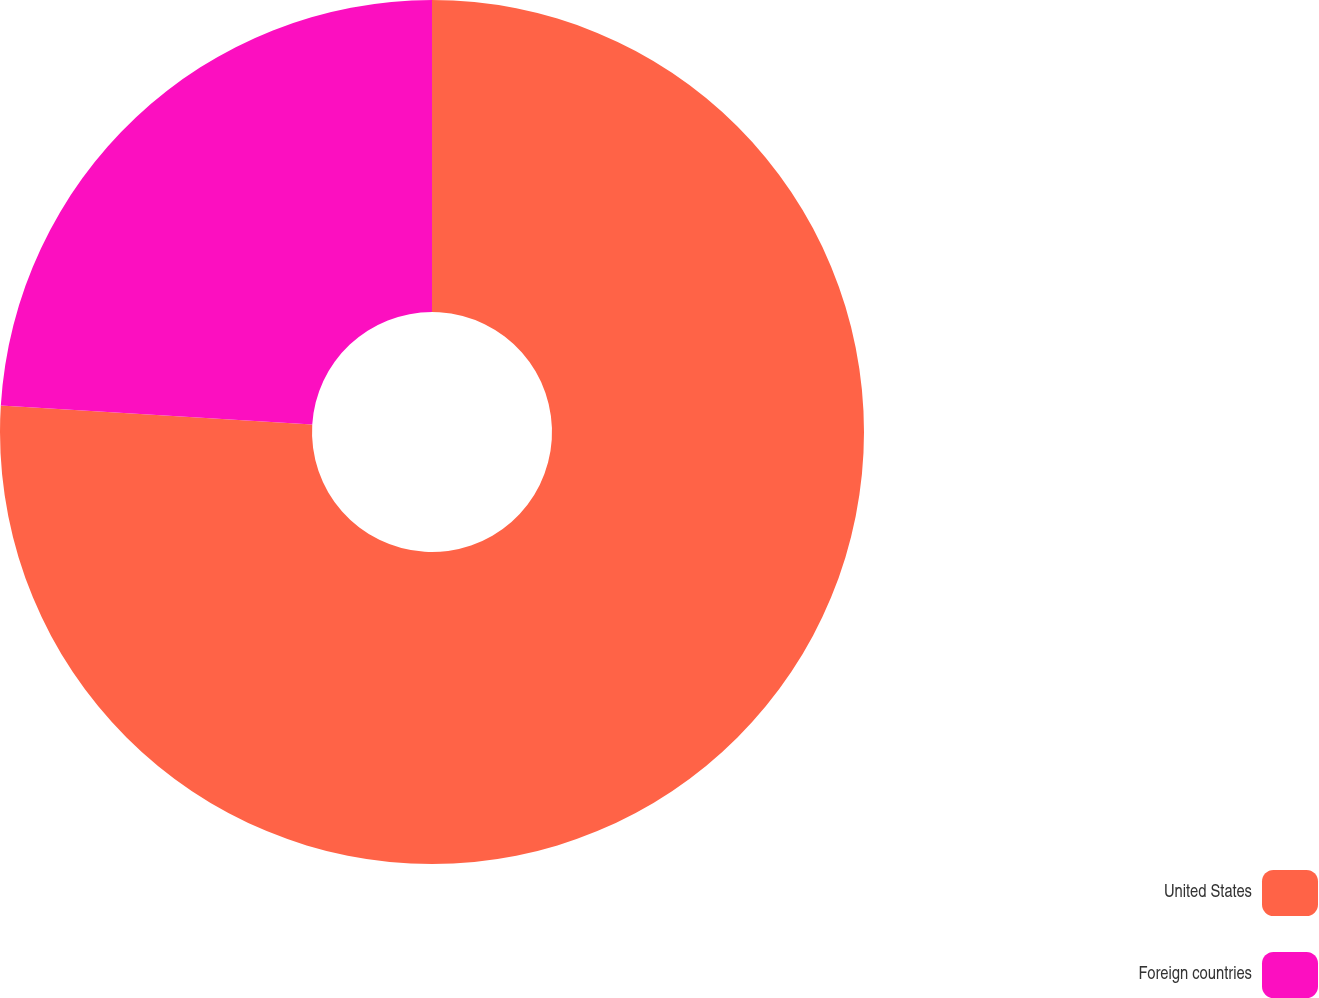<chart> <loc_0><loc_0><loc_500><loc_500><pie_chart><fcel>United States<fcel>Foreign countries<nl><fcel>75.98%<fcel>24.02%<nl></chart> 